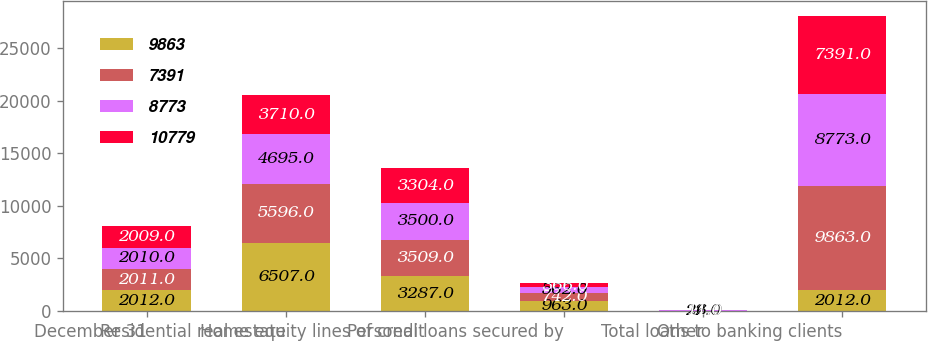Convert chart. <chart><loc_0><loc_0><loc_500><loc_500><stacked_bar_chart><ecel><fcel>December 31<fcel>Residential real estate<fcel>Home equity lines of credit<fcel>Personal loans secured by<fcel>Other<fcel>Total loans to banking clients<nl><fcel>9863<fcel>2012<fcel>6507<fcel>3287<fcel>963<fcel>22<fcel>2012<nl><fcel>7391<fcel>2011<fcel>5596<fcel>3509<fcel>742<fcel>16<fcel>9863<nl><fcel>8773<fcel>2010<fcel>4695<fcel>3500<fcel>562<fcel>16<fcel>8773<nl><fcel>10779<fcel>2009<fcel>3710<fcel>3304<fcel>366<fcel>11<fcel>7391<nl></chart> 